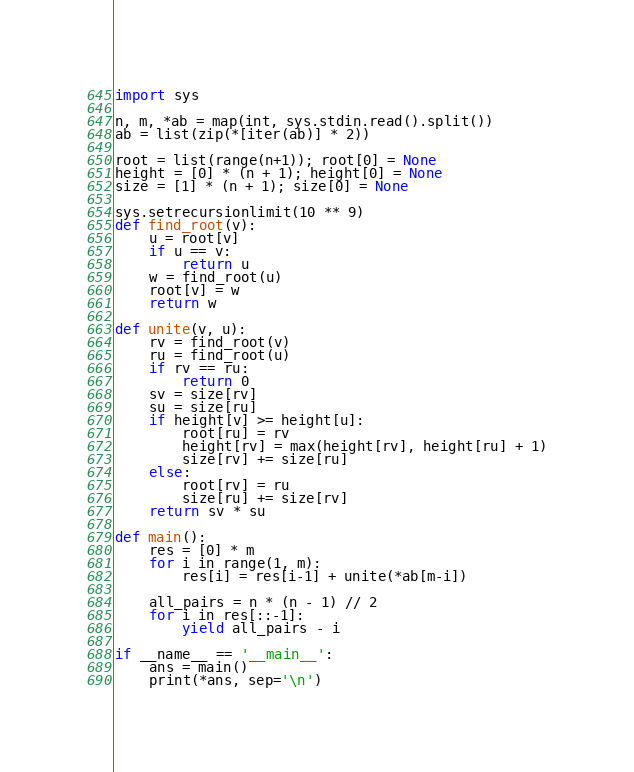<code> <loc_0><loc_0><loc_500><loc_500><_Python_>import sys

n, m, *ab = map(int, sys.stdin.read().split())
ab = list(zip(*[iter(ab)] * 2))

root = list(range(n+1)); root[0] = None
height = [0] * (n + 1); height[0] = None
size = [1] * (n + 1); size[0] = None

sys.setrecursionlimit(10 ** 9)
def find_root(v):
    u = root[v]
    if u == v:
        return u
    w = find_root(u)
    root[v] = w
    return w

def unite(v, u):
    rv = find_root(v)
    ru = find_root(u)
    if rv == ru:
        return 0
    sv = size[rv]
    su = size[ru]
    if height[v] >= height[u]:
        root[ru] = rv
        height[rv] = max(height[rv], height[ru] + 1)
        size[rv] += size[ru]
    else:
        root[rv] = ru
        size[ru] += size[rv]
    return sv * su

def main():
    res = [0] * m
    for i in range(1, m):
        res[i] = res[i-1] + unite(*ab[m-i])

    all_pairs = n * (n - 1) // 2
    for i in res[::-1]:
        yield all_pairs - i

if __name__ == '__main__':
    ans = main()
    print(*ans, sep='\n')
</code> 